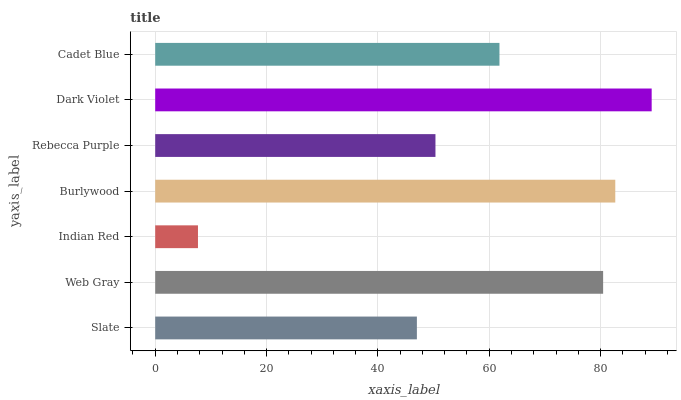Is Indian Red the minimum?
Answer yes or no. Yes. Is Dark Violet the maximum?
Answer yes or no. Yes. Is Web Gray the minimum?
Answer yes or no. No. Is Web Gray the maximum?
Answer yes or no. No. Is Web Gray greater than Slate?
Answer yes or no. Yes. Is Slate less than Web Gray?
Answer yes or no. Yes. Is Slate greater than Web Gray?
Answer yes or no. No. Is Web Gray less than Slate?
Answer yes or no. No. Is Cadet Blue the high median?
Answer yes or no. Yes. Is Cadet Blue the low median?
Answer yes or no. Yes. Is Web Gray the high median?
Answer yes or no. No. Is Burlywood the low median?
Answer yes or no. No. 